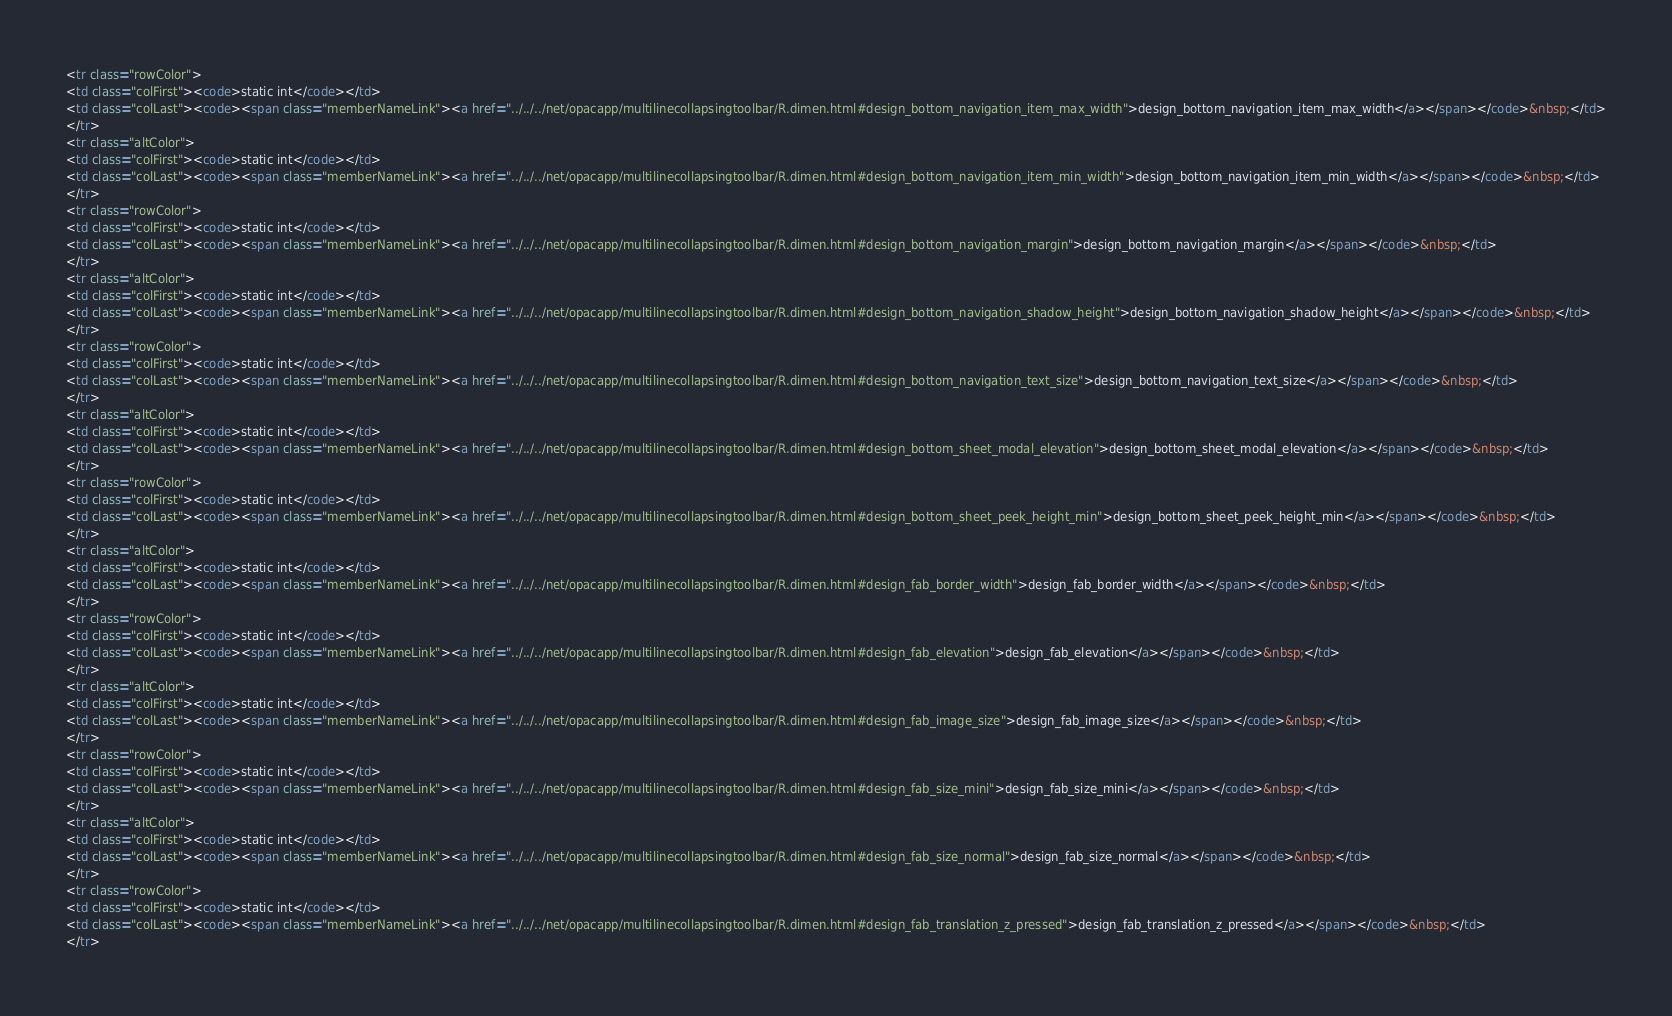<code> <loc_0><loc_0><loc_500><loc_500><_HTML_><tr class="rowColor">
<td class="colFirst"><code>static int</code></td>
<td class="colLast"><code><span class="memberNameLink"><a href="../../../net/opacapp/multilinecollapsingtoolbar/R.dimen.html#design_bottom_navigation_item_max_width">design_bottom_navigation_item_max_width</a></span></code>&nbsp;</td>
</tr>
<tr class="altColor">
<td class="colFirst"><code>static int</code></td>
<td class="colLast"><code><span class="memberNameLink"><a href="../../../net/opacapp/multilinecollapsingtoolbar/R.dimen.html#design_bottom_navigation_item_min_width">design_bottom_navigation_item_min_width</a></span></code>&nbsp;</td>
</tr>
<tr class="rowColor">
<td class="colFirst"><code>static int</code></td>
<td class="colLast"><code><span class="memberNameLink"><a href="../../../net/opacapp/multilinecollapsingtoolbar/R.dimen.html#design_bottom_navigation_margin">design_bottom_navigation_margin</a></span></code>&nbsp;</td>
</tr>
<tr class="altColor">
<td class="colFirst"><code>static int</code></td>
<td class="colLast"><code><span class="memberNameLink"><a href="../../../net/opacapp/multilinecollapsingtoolbar/R.dimen.html#design_bottom_navigation_shadow_height">design_bottom_navigation_shadow_height</a></span></code>&nbsp;</td>
</tr>
<tr class="rowColor">
<td class="colFirst"><code>static int</code></td>
<td class="colLast"><code><span class="memberNameLink"><a href="../../../net/opacapp/multilinecollapsingtoolbar/R.dimen.html#design_bottom_navigation_text_size">design_bottom_navigation_text_size</a></span></code>&nbsp;</td>
</tr>
<tr class="altColor">
<td class="colFirst"><code>static int</code></td>
<td class="colLast"><code><span class="memberNameLink"><a href="../../../net/opacapp/multilinecollapsingtoolbar/R.dimen.html#design_bottom_sheet_modal_elevation">design_bottom_sheet_modal_elevation</a></span></code>&nbsp;</td>
</tr>
<tr class="rowColor">
<td class="colFirst"><code>static int</code></td>
<td class="colLast"><code><span class="memberNameLink"><a href="../../../net/opacapp/multilinecollapsingtoolbar/R.dimen.html#design_bottom_sheet_peek_height_min">design_bottom_sheet_peek_height_min</a></span></code>&nbsp;</td>
</tr>
<tr class="altColor">
<td class="colFirst"><code>static int</code></td>
<td class="colLast"><code><span class="memberNameLink"><a href="../../../net/opacapp/multilinecollapsingtoolbar/R.dimen.html#design_fab_border_width">design_fab_border_width</a></span></code>&nbsp;</td>
</tr>
<tr class="rowColor">
<td class="colFirst"><code>static int</code></td>
<td class="colLast"><code><span class="memberNameLink"><a href="../../../net/opacapp/multilinecollapsingtoolbar/R.dimen.html#design_fab_elevation">design_fab_elevation</a></span></code>&nbsp;</td>
</tr>
<tr class="altColor">
<td class="colFirst"><code>static int</code></td>
<td class="colLast"><code><span class="memberNameLink"><a href="../../../net/opacapp/multilinecollapsingtoolbar/R.dimen.html#design_fab_image_size">design_fab_image_size</a></span></code>&nbsp;</td>
</tr>
<tr class="rowColor">
<td class="colFirst"><code>static int</code></td>
<td class="colLast"><code><span class="memberNameLink"><a href="../../../net/opacapp/multilinecollapsingtoolbar/R.dimen.html#design_fab_size_mini">design_fab_size_mini</a></span></code>&nbsp;</td>
</tr>
<tr class="altColor">
<td class="colFirst"><code>static int</code></td>
<td class="colLast"><code><span class="memberNameLink"><a href="../../../net/opacapp/multilinecollapsingtoolbar/R.dimen.html#design_fab_size_normal">design_fab_size_normal</a></span></code>&nbsp;</td>
</tr>
<tr class="rowColor">
<td class="colFirst"><code>static int</code></td>
<td class="colLast"><code><span class="memberNameLink"><a href="../../../net/opacapp/multilinecollapsingtoolbar/R.dimen.html#design_fab_translation_z_pressed">design_fab_translation_z_pressed</a></span></code>&nbsp;</td>
</tr></code> 